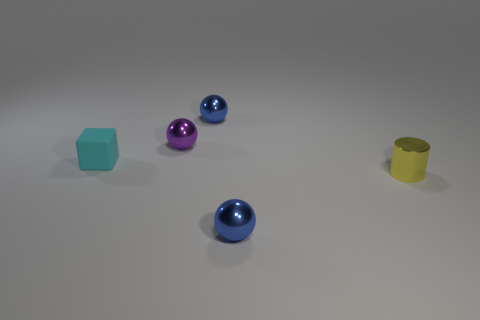Subtract all blue balls. How many balls are left? 1 Add 2 blocks. How many objects exist? 7 Subtract all blue spheres. How many spheres are left? 1 Subtract 0 gray balls. How many objects are left? 5 Subtract all balls. How many objects are left? 2 Subtract 1 cubes. How many cubes are left? 0 Subtract all cyan balls. Subtract all red cylinders. How many balls are left? 3 Subtract all purple cylinders. How many blue spheres are left? 2 Subtract all small blue things. Subtract all yellow cylinders. How many objects are left? 2 Add 1 purple things. How many purple things are left? 2 